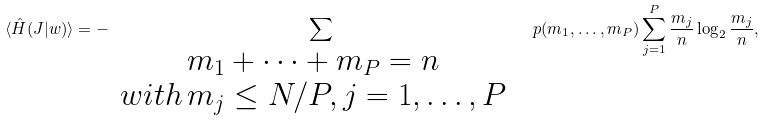Convert formula to latex. <formula><loc_0><loc_0><loc_500><loc_500>\langle \hat { H } ( J | w ) \rangle = - \sum _ { \begin{array} { c c } m _ { 1 } + \dots + m _ { P } = n & \\ w i t h \, m _ { j } \leq N / P , j = 1 , \dots , P & \end{array} } p ( m _ { 1 } , \dots , m _ { P } ) \sum _ { j = 1 } ^ { P } \frac { m _ { j } } { n } \log _ { 2 } \frac { m _ { j } } { n } ,</formula> 